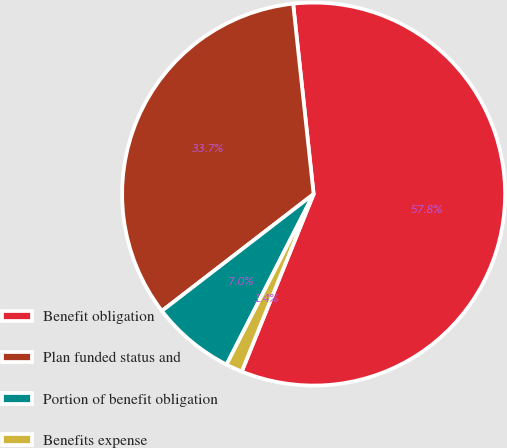Convert chart to OTSL. <chart><loc_0><loc_0><loc_500><loc_500><pie_chart><fcel>Benefit obligation<fcel>Plan funded status and<fcel>Portion of benefit obligation<fcel>Benefits expense<nl><fcel>57.83%<fcel>33.74%<fcel>7.04%<fcel>1.39%<nl></chart> 